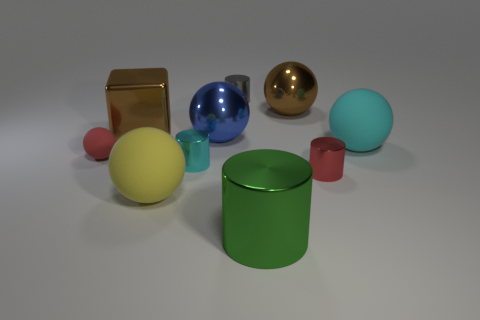Subtract all large brown spheres. How many spheres are left? 4 Subtract all red cylinders. Subtract all cyan balls. How many cylinders are left? 3 Subtract all gray blocks. How many blue cylinders are left? 0 Subtract all big purple rubber balls. Subtract all large green things. How many objects are left? 9 Add 9 small red metal objects. How many small red metal objects are left? 10 Add 3 tiny cyan metallic objects. How many tiny cyan metallic objects exist? 4 Subtract all red spheres. How many spheres are left? 4 Subtract 0 blue cylinders. How many objects are left? 10 Subtract all cubes. How many objects are left? 9 Subtract 2 cylinders. How many cylinders are left? 2 